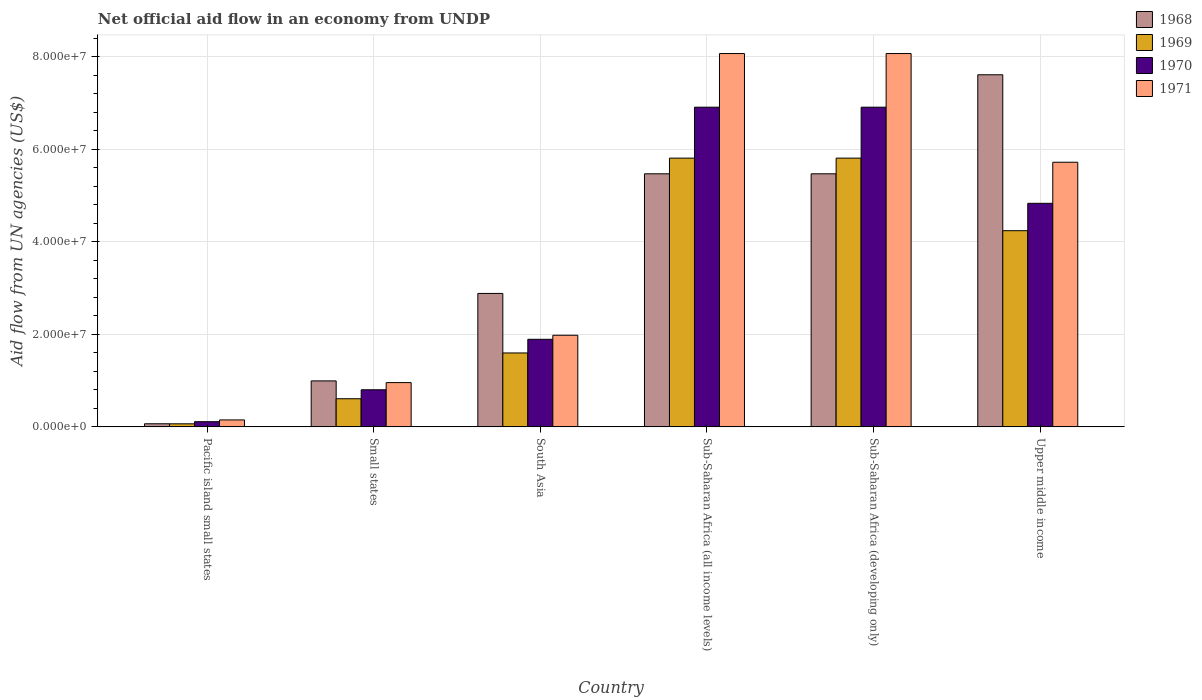Are the number of bars per tick equal to the number of legend labels?
Ensure brevity in your answer.  Yes. How many bars are there on the 5th tick from the right?
Provide a succinct answer. 4. What is the label of the 4th group of bars from the left?
Make the answer very short. Sub-Saharan Africa (all income levels). What is the net official aid flow in 1968 in South Asia?
Provide a short and direct response. 2.88e+07. Across all countries, what is the maximum net official aid flow in 1970?
Provide a short and direct response. 6.91e+07. Across all countries, what is the minimum net official aid flow in 1971?
Your answer should be very brief. 1.50e+06. In which country was the net official aid flow in 1970 maximum?
Your answer should be very brief. Sub-Saharan Africa (all income levels). In which country was the net official aid flow in 1969 minimum?
Ensure brevity in your answer.  Pacific island small states. What is the total net official aid flow in 1968 in the graph?
Your answer should be very brief. 2.25e+08. What is the difference between the net official aid flow in 1971 in Sub-Saharan Africa (developing only) and that in Upper middle income?
Your answer should be compact. 2.35e+07. What is the difference between the net official aid flow in 1968 in Small states and the net official aid flow in 1969 in South Asia?
Offer a very short reply. -6.04e+06. What is the average net official aid flow in 1970 per country?
Your answer should be compact. 3.58e+07. What is the difference between the net official aid flow of/in 1968 and net official aid flow of/in 1971 in Pacific island small states?
Provide a short and direct response. -8.30e+05. What is the ratio of the net official aid flow in 1968 in South Asia to that in Sub-Saharan Africa (developing only)?
Offer a very short reply. 0.53. Is the net official aid flow in 1969 in South Asia less than that in Sub-Saharan Africa (all income levels)?
Provide a short and direct response. Yes. Is the difference between the net official aid flow in 1968 in Pacific island small states and Sub-Saharan Africa (developing only) greater than the difference between the net official aid flow in 1971 in Pacific island small states and Sub-Saharan Africa (developing only)?
Make the answer very short. Yes. What is the difference between the highest and the second highest net official aid flow in 1970?
Provide a succinct answer. 2.08e+07. What is the difference between the highest and the lowest net official aid flow in 1969?
Offer a terse response. 5.74e+07. Is it the case that in every country, the sum of the net official aid flow in 1971 and net official aid flow in 1969 is greater than the sum of net official aid flow in 1968 and net official aid flow in 1970?
Provide a short and direct response. No. What does the 4th bar from the left in South Asia represents?
Your answer should be compact. 1971. What does the 4th bar from the right in Sub-Saharan Africa (developing only) represents?
Keep it short and to the point. 1968. Is it the case that in every country, the sum of the net official aid flow in 1969 and net official aid flow in 1971 is greater than the net official aid flow in 1970?
Offer a terse response. Yes. How many bars are there?
Your answer should be very brief. 24. Are all the bars in the graph horizontal?
Make the answer very short. No. What is the difference between two consecutive major ticks on the Y-axis?
Give a very brief answer. 2.00e+07. Does the graph contain any zero values?
Give a very brief answer. No. Where does the legend appear in the graph?
Provide a short and direct response. Top right. What is the title of the graph?
Provide a short and direct response. Net official aid flow in an economy from UNDP. Does "1981" appear as one of the legend labels in the graph?
Your answer should be compact. No. What is the label or title of the X-axis?
Your response must be concise. Country. What is the label or title of the Y-axis?
Give a very brief answer. Aid flow from UN agencies (US$). What is the Aid flow from UN agencies (US$) in 1968 in Pacific island small states?
Your answer should be very brief. 6.70e+05. What is the Aid flow from UN agencies (US$) of 1970 in Pacific island small states?
Offer a very short reply. 1.12e+06. What is the Aid flow from UN agencies (US$) in 1971 in Pacific island small states?
Make the answer very short. 1.50e+06. What is the Aid flow from UN agencies (US$) of 1968 in Small states?
Ensure brevity in your answer.  9.94e+06. What is the Aid flow from UN agencies (US$) in 1969 in Small states?
Make the answer very short. 6.08e+06. What is the Aid flow from UN agencies (US$) in 1970 in Small states?
Offer a very short reply. 8.02e+06. What is the Aid flow from UN agencies (US$) of 1971 in Small states?
Give a very brief answer. 9.57e+06. What is the Aid flow from UN agencies (US$) of 1968 in South Asia?
Offer a very short reply. 2.88e+07. What is the Aid flow from UN agencies (US$) of 1969 in South Asia?
Your response must be concise. 1.60e+07. What is the Aid flow from UN agencies (US$) in 1970 in South Asia?
Provide a succinct answer. 1.89e+07. What is the Aid flow from UN agencies (US$) of 1971 in South Asia?
Provide a short and direct response. 1.98e+07. What is the Aid flow from UN agencies (US$) in 1968 in Sub-Saharan Africa (all income levels)?
Offer a terse response. 5.47e+07. What is the Aid flow from UN agencies (US$) of 1969 in Sub-Saharan Africa (all income levels)?
Offer a terse response. 5.81e+07. What is the Aid flow from UN agencies (US$) of 1970 in Sub-Saharan Africa (all income levels)?
Provide a short and direct response. 6.91e+07. What is the Aid flow from UN agencies (US$) of 1971 in Sub-Saharan Africa (all income levels)?
Your answer should be very brief. 8.07e+07. What is the Aid flow from UN agencies (US$) in 1968 in Sub-Saharan Africa (developing only)?
Provide a short and direct response. 5.47e+07. What is the Aid flow from UN agencies (US$) of 1969 in Sub-Saharan Africa (developing only)?
Ensure brevity in your answer.  5.81e+07. What is the Aid flow from UN agencies (US$) in 1970 in Sub-Saharan Africa (developing only)?
Offer a very short reply. 6.91e+07. What is the Aid flow from UN agencies (US$) in 1971 in Sub-Saharan Africa (developing only)?
Offer a terse response. 8.07e+07. What is the Aid flow from UN agencies (US$) of 1968 in Upper middle income?
Keep it short and to the point. 7.61e+07. What is the Aid flow from UN agencies (US$) of 1969 in Upper middle income?
Make the answer very short. 4.24e+07. What is the Aid flow from UN agencies (US$) of 1970 in Upper middle income?
Provide a short and direct response. 4.83e+07. What is the Aid flow from UN agencies (US$) of 1971 in Upper middle income?
Keep it short and to the point. 5.72e+07. Across all countries, what is the maximum Aid flow from UN agencies (US$) of 1968?
Ensure brevity in your answer.  7.61e+07. Across all countries, what is the maximum Aid flow from UN agencies (US$) in 1969?
Offer a terse response. 5.81e+07. Across all countries, what is the maximum Aid flow from UN agencies (US$) in 1970?
Your answer should be very brief. 6.91e+07. Across all countries, what is the maximum Aid flow from UN agencies (US$) of 1971?
Ensure brevity in your answer.  8.07e+07. Across all countries, what is the minimum Aid flow from UN agencies (US$) of 1968?
Give a very brief answer. 6.70e+05. Across all countries, what is the minimum Aid flow from UN agencies (US$) in 1969?
Make the answer very short. 6.60e+05. Across all countries, what is the minimum Aid flow from UN agencies (US$) in 1970?
Your answer should be compact. 1.12e+06. Across all countries, what is the minimum Aid flow from UN agencies (US$) in 1971?
Offer a terse response. 1.50e+06. What is the total Aid flow from UN agencies (US$) of 1968 in the graph?
Offer a very short reply. 2.25e+08. What is the total Aid flow from UN agencies (US$) of 1969 in the graph?
Offer a terse response. 1.81e+08. What is the total Aid flow from UN agencies (US$) in 1970 in the graph?
Your response must be concise. 2.15e+08. What is the total Aid flow from UN agencies (US$) of 1971 in the graph?
Your response must be concise. 2.50e+08. What is the difference between the Aid flow from UN agencies (US$) in 1968 in Pacific island small states and that in Small states?
Keep it short and to the point. -9.27e+06. What is the difference between the Aid flow from UN agencies (US$) in 1969 in Pacific island small states and that in Small states?
Your answer should be very brief. -5.42e+06. What is the difference between the Aid flow from UN agencies (US$) in 1970 in Pacific island small states and that in Small states?
Your answer should be very brief. -6.90e+06. What is the difference between the Aid flow from UN agencies (US$) in 1971 in Pacific island small states and that in Small states?
Make the answer very short. -8.07e+06. What is the difference between the Aid flow from UN agencies (US$) in 1968 in Pacific island small states and that in South Asia?
Give a very brief answer. -2.82e+07. What is the difference between the Aid flow from UN agencies (US$) in 1969 in Pacific island small states and that in South Asia?
Give a very brief answer. -1.53e+07. What is the difference between the Aid flow from UN agencies (US$) in 1970 in Pacific island small states and that in South Asia?
Your response must be concise. -1.78e+07. What is the difference between the Aid flow from UN agencies (US$) in 1971 in Pacific island small states and that in South Asia?
Give a very brief answer. -1.83e+07. What is the difference between the Aid flow from UN agencies (US$) in 1968 in Pacific island small states and that in Sub-Saharan Africa (all income levels)?
Your answer should be compact. -5.40e+07. What is the difference between the Aid flow from UN agencies (US$) in 1969 in Pacific island small states and that in Sub-Saharan Africa (all income levels)?
Provide a short and direct response. -5.74e+07. What is the difference between the Aid flow from UN agencies (US$) of 1970 in Pacific island small states and that in Sub-Saharan Africa (all income levels)?
Make the answer very short. -6.80e+07. What is the difference between the Aid flow from UN agencies (US$) of 1971 in Pacific island small states and that in Sub-Saharan Africa (all income levels)?
Your response must be concise. -7.92e+07. What is the difference between the Aid flow from UN agencies (US$) of 1968 in Pacific island small states and that in Sub-Saharan Africa (developing only)?
Provide a succinct answer. -5.40e+07. What is the difference between the Aid flow from UN agencies (US$) in 1969 in Pacific island small states and that in Sub-Saharan Africa (developing only)?
Your answer should be very brief. -5.74e+07. What is the difference between the Aid flow from UN agencies (US$) of 1970 in Pacific island small states and that in Sub-Saharan Africa (developing only)?
Make the answer very short. -6.80e+07. What is the difference between the Aid flow from UN agencies (US$) of 1971 in Pacific island small states and that in Sub-Saharan Africa (developing only)?
Offer a very short reply. -7.92e+07. What is the difference between the Aid flow from UN agencies (US$) in 1968 in Pacific island small states and that in Upper middle income?
Offer a very short reply. -7.54e+07. What is the difference between the Aid flow from UN agencies (US$) of 1969 in Pacific island small states and that in Upper middle income?
Offer a very short reply. -4.18e+07. What is the difference between the Aid flow from UN agencies (US$) in 1970 in Pacific island small states and that in Upper middle income?
Your answer should be compact. -4.72e+07. What is the difference between the Aid flow from UN agencies (US$) in 1971 in Pacific island small states and that in Upper middle income?
Provide a succinct answer. -5.57e+07. What is the difference between the Aid flow from UN agencies (US$) of 1968 in Small states and that in South Asia?
Your answer should be compact. -1.89e+07. What is the difference between the Aid flow from UN agencies (US$) of 1969 in Small states and that in South Asia?
Ensure brevity in your answer.  -9.90e+06. What is the difference between the Aid flow from UN agencies (US$) of 1970 in Small states and that in South Asia?
Ensure brevity in your answer.  -1.09e+07. What is the difference between the Aid flow from UN agencies (US$) of 1971 in Small states and that in South Asia?
Your answer should be very brief. -1.02e+07. What is the difference between the Aid flow from UN agencies (US$) of 1968 in Small states and that in Sub-Saharan Africa (all income levels)?
Offer a terse response. -4.48e+07. What is the difference between the Aid flow from UN agencies (US$) of 1969 in Small states and that in Sub-Saharan Africa (all income levels)?
Provide a short and direct response. -5.20e+07. What is the difference between the Aid flow from UN agencies (US$) of 1970 in Small states and that in Sub-Saharan Africa (all income levels)?
Your answer should be compact. -6.11e+07. What is the difference between the Aid flow from UN agencies (US$) in 1971 in Small states and that in Sub-Saharan Africa (all income levels)?
Give a very brief answer. -7.11e+07. What is the difference between the Aid flow from UN agencies (US$) of 1968 in Small states and that in Sub-Saharan Africa (developing only)?
Make the answer very short. -4.48e+07. What is the difference between the Aid flow from UN agencies (US$) of 1969 in Small states and that in Sub-Saharan Africa (developing only)?
Your answer should be compact. -5.20e+07. What is the difference between the Aid flow from UN agencies (US$) of 1970 in Small states and that in Sub-Saharan Africa (developing only)?
Offer a very short reply. -6.11e+07. What is the difference between the Aid flow from UN agencies (US$) in 1971 in Small states and that in Sub-Saharan Africa (developing only)?
Ensure brevity in your answer.  -7.11e+07. What is the difference between the Aid flow from UN agencies (US$) in 1968 in Small states and that in Upper middle income?
Ensure brevity in your answer.  -6.62e+07. What is the difference between the Aid flow from UN agencies (US$) in 1969 in Small states and that in Upper middle income?
Your response must be concise. -3.63e+07. What is the difference between the Aid flow from UN agencies (US$) in 1970 in Small states and that in Upper middle income?
Offer a very short reply. -4.03e+07. What is the difference between the Aid flow from UN agencies (US$) in 1971 in Small states and that in Upper middle income?
Your answer should be compact. -4.76e+07. What is the difference between the Aid flow from UN agencies (US$) in 1968 in South Asia and that in Sub-Saharan Africa (all income levels)?
Provide a succinct answer. -2.59e+07. What is the difference between the Aid flow from UN agencies (US$) in 1969 in South Asia and that in Sub-Saharan Africa (all income levels)?
Offer a very short reply. -4.21e+07. What is the difference between the Aid flow from UN agencies (US$) of 1970 in South Asia and that in Sub-Saharan Africa (all income levels)?
Offer a terse response. -5.02e+07. What is the difference between the Aid flow from UN agencies (US$) of 1971 in South Asia and that in Sub-Saharan Africa (all income levels)?
Ensure brevity in your answer.  -6.09e+07. What is the difference between the Aid flow from UN agencies (US$) in 1968 in South Asia and that in Sub-Saharan Africa (developing only)?
Keep it short and to the point. -2.59e+07. What is the difference between the Aid flow from UN agencies (US$) of 1969 in South Asia and that in Sub-Saharan Africa (developing only)?
Provide a short and direct response. -4.21e+07. What is the difference between the Aid flow from UN agencies (US$) in 1970 in South Asia and that in Sub-Saharan Africa (developing only)?
Offer a terse response. -5.02e+07. What is the difference between the Aid flow from UN agencies (US$) in 1971 in South Asia and that in Sub-Saharan Africa (developing only)?
Give a very brief answer. -6.09e+07. What is the difference between the Aid flow from UN agencies (US$) in 1968 in South Asia and that in Upper middle income?
Make the answer very short. -4.73e+07. What is the difference between the Aid flow from UN agencies (US$) in 1969 in South Asia and that in Upper middle income?
Ensure brevity in your answer.  -2.64e+07. What is the difference between the Aid flow from UN agencies (US$) of 1970 in South Asia and that in Upper middle income?
Ensure brevity in your answer.  -2.94e+07. What is the difference between the Aid flow from UN agencies (US$) of 1971 in South Asia and that in Upper middle income?
Provide a short and direct response. -3.74e+07. What is the difference between the Aid flow from UN agencies (US$) of 1968 in Sub-Saharan Africa (all income levels) and that in Sub-Saharan Africa (developing only)?
Offer a very short reply. 0. What is the difference between the Aid flow from UN agencies (US$) of 1971 in Sub-Saharan Africa (all income levels) and that in Sub-Saharan Africa (developing only)?
Your answer should be very brief. 0. What is the difference between the Aid flow from UN agencies (US$) of 1968 in Sub-Saharan Africa (all income levels) and that in Upper middle income?
Make the answer very short. -2.14e+07. What is the difference between the Aid flow from UN agencies (US$) of 1969 in Sub-Saharan Africa (all income levels) and that in Upper middle income?
Your answer should be very brief. 1.57e+07. What is the difference between the Aid flow from UN agencies (US$) in 1970 in Sub-Saharan Africa (all income levels) and that in Upper middle income?
Offer a terse response. 2.08e+07. What is the difference between the Aid flow from UN agencies (US$) of 1971 in Sub-Saharan Africa (all income levels) and that in Upper middle income?
Provide a succinct answer. 2.35e+07. What is the difference between the Aid flow from UN agencies (US$) in 1968 in Sub-Saharan Africa (developing only) and that in Upper middle income?
Provide a short and direct response. -2.14e+07. What is the difference between the Aid flow from UN agencies (US$) of 1969 in Sub-Saharan Africa (developing only) and that in Upper middle income?
Your answer should be compact. 1.57e+07. What is the difference between the Aid flow from UN agencies (US$) of 1970 in Sub-Saharan Africa (developing only) and that in Upper middle income?
Offer a terse response. 2.08e+07. What is the difference between the Aid flow from UN agencies (US$) in 1971 in Sub-Saharan Africa (developing only) and that in Upper middle income?
Your response must be concise. 2.35e+07. What is the difference between the Aid flow from UN agencies (US$) in 1968 in Pacific island small states and the Aid flow from UN agencies (US$) in 1969 in Small states?
Your response must be concise. -5.41e+06. What is the difference between the Aid flow from UN agencies (US$) in 1968 in Pacific island small states and the Aid flow from UN agencies (US$) in 1970 in Small states?
Offer a very short reply. -7.35e+06. What is the difference between the Aid flow from UN agencies (US$) of 1968 in Pacific island small states and the Aid flow from UN agencies (US$) of 1971 in Small states?
Offer a terse response. -8.90e+06. What is the difference between the Aid flow from UN agencies (US$) in 1969 in Pacific island small states and the Aid flow from UN agencies (US$) in 1970 in Small states?
Offer a terse response. -7.36e+06. What is the difference between the Aid flow from UN agencies (US$) of 1969 in Pacific island small states and the Aid flow from UN agencies (US$) of 1971 in Small states?
Make the answer very short. -8.91e+06. What is the difference between the Aid flow from UN agencies (US$) in 1970 in Pacific island small states and the Aid flow from UN agencies (US$) in 1971 in Small states?
Offer a terse response. -8.45e+06. What is the difference between the Aid flow from UN agencies (US$) in 1968 in Pacific island small states and the Aid flow from UN agencies (US$) in 1969 in South Asia?
Offer a very short reply. -1.53e+07. What is the difference between the Aid flow from UN agencies (US$) of 1968 in Pacific island small states and the Aid flow from UN agencies (US$) of 1970 in South Asia?
Give a very brief answer. -1.83e+07. What is the difference between the Aid flow from UN agencies (US$) in 1968 in Pacific island small states and the Aid flow from UN agencies (US$) in 1971 in South Asia?
Your answer should be very brief. -1.91e+07. What is the difference between the Aid flow from UN agencies (US$) of 1969 in Pacific island small states and the Aid flow from UN agencies (US$) of 1970 in South Asia?
Provide a short and direct response. -1.83e+07. What is the difference between the Aid flow from UN agencies (US$) of 1969 in Pacific island small states and the Aid flow from UN agencies (US$) of 1971 in South Asia?
Ensure brevity in your answer.  -1.92e+07. What is the difference between the Aid flow from UN agencies (US$) of 1970 in Pacific island small states and the Aid flow from UN agencies (US$) of 1971 in South Asia?
Keep it short and to the point. -1.87e+07. What is the difference between the Aid flow from UN agencies (US$) of 1968 in Pacific island small states and the Aid flow from UN agencies (US$) of 1969 in Sub-Saharan Africa (all income levels)?
Your answer should be very brief. -5.74e+07. What is the difference between the Aid flow from UN agencies (US$) in 1968 in Pacific island small states and the Aid flow from UN agencies (US$) in 1970 in Sub-Saharan Africa (all income levels)?
Offer a terse response. -6.84e+07. What is the difference between the Aid flow from UN agencies (US$) of 1968 in Pacific island small states and the Aid flow from UN agencies (US$) of 1971 in Sub-Saharan Africa (all income levels)?
Make the answer very short. -8.00e+07. What is the difference between the Aid flow from UN agencies (US$) in 1969 in Pacific island small states and the Aid flow from UN agencies (US$) in 1970 in Sub-Saharan Africa (all income levels)?
Ensure brevity in your answer.  -6.84e+07. What is the difference between the Aid flow from UN agencies (US$) in 1969 in Pacific island small states and the Aid flow from UN agencies (US$) in 1971 in Sub-Saharan Africa (all income levels)?
Offer a very short reply. -8.00e+07. What is the difference between the Aid flow from UN agencies (US$) in 1970 in Pacific island small states and the Aid flow from UN agencies (US$) in 1971 in Sub-Saharan Africa (all income levels)?
Offer a very short reply. -7.96e+07. What is the difference between the Aid flow from UN agencies (US$) in 1968 in Pacific island small states and the Aid flow from UN agencies (US$) in 1969 in Sub-Saharan Africa (developing only)?
Offer a very short reply. -5.74e+07. What is the difference between the Aid flow from UN agencies (US$) in 1968 in Pacific island small states and the Aid flow from UN agencies (US$) in 1970 in Sub-Saharan Africa (developing only)?
Your answer should be compact. -6.84e+07. What is the difference between the Aid flow from UN agencies (US$) in 1968 in Pacific island small states and the Aid flow from UN agencies (US$) in 1971 in Sub-Saharan Africa (developing only)?
Offer a very short reply. -8.00e+07. What is the difference between the Aid flow from UN agencies (US$) of 1969 in Pacific island small states and the Aid flow from UN agencies (US$) of 1970 in Sub-Saharan Africa (developing only)?
Offer a very short reply. -6.84e+07. What is the difference between the Aid flow from UN agencies (US$) of 1969 in Pacific island small states and the Aid flow from UN agencies (US$) of 1971 in Sub-Saharan Africa (developing only)?
Provide a succinct answer. -8.00e+07. What is the difference between the Aid flow from UN agencies (US$) in 1970 in Pacific island small states and the Aid flow from UN agencies (US$) in 1971 in Sub-Saharan Africa (developing only)?
Keep it short and to the point. -7.96e+07. What is the difference between the Aid flow from UN agencies (US$) in 1968 in Pacific island small states and the Aid flow from UN agencies (US$) in 1969 in Upper middle income?
Give a very brief answer. -4.17e+07. What is the difference between the Aid flow from UN agencies (US$) of 1968 in Pacific island small states and the Aid flow from UN agencies (US$) of 1970 in Upper middle income?
Ensure brevity in your answer.  -4.77e+07. What is the difference between the Aid flow from UN agencies (US$) in 1968 in Pacific island small states and the Aid flow from UN agencies (US$) in 1971 in Upper middle income?
Your answer should be compact. -5.65e+07. What is the difference between the Aid flow from UN agencies (US$) of 1969 in Pacific island small states and the Aid flow from UN agencies (US$) of 1970 in Upper middle income?
Your answer should be compact. -4.77e+07. What is the difference between the Aid flow from UN agencies (US$) of 1969 in Pacific island small states and the Aid flow from UN agencies (US$) of 1971 in Upper middle income?
Your answer should be very brief. -5.66e+07. What is the difference between the Aid flow from UN agencies (US$) in 1970 in Pacific island small states and the Aid flow from UN agencies (US$) in 1971 in Upper middle income?
Provide a succinct answer. -5.61e+07. What is the difference between the Aid flow from UN agencies (US$) in 1968 in Small states and the Aid flow from UN agencies (US$) in 1969 in South Asia?
Your answer should be compact. -6.04e+06. What is the difference between the Aid flow from UN agencies (US$) of 1968 in Small states and the Aid flow from UN agencies (US$) of 1970 in South Asia?
Provide a short and direct response. -8.99e+06. What is the difference between the Aid flow from UN agencies (US$) in 1968 in Small states and the Aid flow from UN agencies (US$) in 1971 in South Asia?
Your answer should be compact. -9.87e+06. What is the difference between the Aid flow from UN agencies (US$) in 1969 in Small states and the Aid flow from UN agencies (US$) in 1970 in South Asia?
Keep it short and to the point. -1.28e+07. What is the difference between the Aid flow from UN agencies (US$) in 1969 in Small states and the Aid flow from UN agencies (US$) in 1971 in South Asia?
Your response must be concise. -1.37e+07. What is the difference between the Aid flow from UN agencies (US$) of 1970 in Small states and the Aid flow from UN agencies (US$) of 1971 in South Asia?
Offer a very short reply. -1.18e+07. What is the difference between the Aid flow from UN agencies (US$) of 1968 in Small states and the Aid flow from UN agencies (US$) of 1969 in Sub-Saharan Africa (all income levels)?
Your answer should be very brief. -4.82e+07. What is the difference between the Aid flow from UN agencies (US$) of 1968 in Small states and the Aid flow from UN agencies (US$) of 1970 in Sub-Saharan Africa (all income levels)?
Your answer should be compact. -5.92e+07. What is the difference between the Aid flow from UN agencies (US$) of 1968 in Small states and the Aid flow from UN agencies (US$) of 1971 in Sub-Saharan Africa (all income levels)?
Provide a short and direct response. -7.08e+07. What is the difference between the Aid flow from UN agencies (US$) in 1969 in Small states and the Aid flow from UN agencies (US$) in 1970 in Sub-Saharan Africa (all income levels)?
Provide a short and direct response. -6.30e+07. What is the difference between the Aid flow from UN agencies (US$) in 1969 in Small states and the Aid flow from UN agencies (US$) in 1971 in Sub-Saharan Africa (all income levels)?
Ensure brevity in your answer.  -7.46e+07. What is the difference between the Aid flow from UN agencies (US$) in 1970 in Small states and the Aid flow from UN agencies (US$) in 1971 in Sub-Saharan Africa (all income levels)?
Give a very brief answer. -7.27e+07. What is the difference between the Aid flow from UN agencies (US$) in 1968 in Small states and the Aid flow from UN agencies (US$) in 1969 in Sub-Saharan Africa (developing only)?
Your answer should be very brief. -4.82e+07. What is the difference between the Aid flow from UN agencies (US$) in 1968 in Small states and the Aid flow from UN agencies (US$) in 1970 in Sub-Saharan Africa (developing only)?
Provide a succinct answer. -5.92e+07. What is the difference between the Aid flow from UN agencies (US$) in 1968 in Small states and the Aid flow from UN agencies (US$) in 1971 in Sub-Saharan Africa (developing only)?
Ensure brevity in your answer.  -7.08e+07. What is the difference between the Aid flow from UN agencies (US$) of 1969 in Small states and the Aid flow from UN agencies (US$) of 1970 in Sub-Saharan Africa (developing only)?
Your answer should be compact. -6.30e+07. What is the difference between the Aid flow from UN agencies (US$) in 1969 in Small states and the Aid flow from UN agencies (US$) in 1971 in Sub-Saharan Africa (developing only)?
Give a very brief answer. -7.46e+07. What is the difference between the Aid flow from UN agencies (US$) in 1970 in Small states and the Aid flow from UN agencies (US$) in 1971 in Sub-Saharan Africa (developing only)?
Provide a short and direct response. -7.27e+07. What is the difference between the Aid flow from UN agencies (US$) of 1968 in Small states and the Aid flow from UN agencies (US$) of 1969 in Upper middle income?
Your answer should be very brief. -3.25e+07. What is the difference between the Aid flow from UN agencies (US$) in 1968 in Small states and the Aid flow from UN agencies (US$) in 1970 in Upper middle income?
Give a very brief answer. -3.84e+07. What is the difference between the Aid flow from UN agencies (US$) of 1968 in Small states and the Aid flow from UN agencies (US$) of 1971 in Upper middle income?
Offer a terse response. -4.73e+07. What is the difference between the Aid flow from UN agencies (US$) of 1969 in Small states and the Aid flow from UN agencies (US$) of 1970 in Upper middle income?
Keep it short and to the point. -4.22e+07. What is the difference between the Aid flow from UN agencies (US$) of 1969 in Small states and the Aid flow from UN agencies (US$) of 1971 in Upper middle income?
Provide a short and direct response. -5.11e+07. What is the difference between the Aid flow from UN agencies (US$) in 1970 in Small states and the Aid flow from UN agencies (US$) in 1971 in Upper middle income?
Your answer should be compact. -4.92e+07. What is the difference between the Aid flow from UN agencies (US$) of 1968 in South Asia and the Aid flow from UN agencies (US$) of 1969 in Sub-Saharan Africa (all income levels)?
Ensure brevity in your answer.  -2.92e+07. What is the difference between the Aid flow from UN agencies (US$) of 1968 in South Asia and the Aid flow from UN agencies (US$) of 1970 in Sub-Saharan Africa (all income levels)?
Make the answer very short. -4.03e+07. What is the difference between the Aid flow from UN agencies (US$) of 1968 in South Asia and the Aid flow from UN agencies (US$) of 1971 in Sub-Saharan Africa (all income levels)?
Your answer should be compact. -5.19e+07. What is the difference between the Aid flow from UN agencies (US$) in 1969 in South Asia and the Aid flow from UN agencies (US$) in 1970 in Sub-Saharan Africa (all income levels)?
Your answer should be compact. -5.31e+07. What is the difference between the Aid flow from UN agencies (US$) of 1969 in South Asia and the Aid flow from UN agencies (US$) of 1971 in Sub-Saharan Africa (all income levels)?
Make the answer very short. -6.47e+07. What is the difference between the Aid flow from UN agencies (US$) in 1970 in South Asia and the Aid flow from UN agencies (US$) in 1971 in Sub-Saharan Africa (all income levels)?
Ensure brevity in your answer.  -6.18e+07. What is the difference between the Aid flow from UN agencies (US$) in 1968 in South Asia and the Aid flow from UN agencies (US$) in 1969 in Sub-Saharan Africa (developing only)?
Provide a succinct answer. -2.92e+07. What is the difference between the Aid flow from UN agencies (US$) in 1968 in South Asia and the Aid flow from UN agencies (US$) in 1970 in Sub-Saharan Africa (developing only)?
Keep it short and to the point. -4.03e+07. What is the difference between the Aid flow from UN agencies (US$) in 1968 in South Asia and the Aid flow from UN agencies (US$) in 1971 in Sub-Saharan Africa (developing only)?
Your response must be concise. -5.19e+07. What is the difference between the Aid flow from UN agencies (US$) of 1969 in South Asia and the Aid flow from UN agencies (US$) of 1970 in Sub-Saharan Africa (developing only)?
Make the answer very short. -5.31e+07. What is the difference between the Aid flow from UN agencies (US$) of 1969 in South Asia and the Aid flow from UN agencies (US$) of 1971 in Sub-Saharan Africa (developing only)?
Offer a terse response. -6.47e+07. What is the difference between the Aid flow from UN agencies (US$) of 1970 in South Asia and the Aid flow from UN agencies (US$) of 1971 in Sub-Saharan Africa (developing only)?
Offer a terse response. -6.18e+07. What is the difference between the Aid flow from UN agencies (US$) of 1968 in South Asia and the Aid flow from UN agencies (US$) of 1969 in Upper middle income?
Your answer should be very brief. -1.36e+07. What is the difference between the Aid flow from UN agencies (US$) in 1968 in South Asia and the Aid flow from UN agencies (US$) in 1970 in Upper middle income?
Offer a terse response. -1.95e+07. What is the difference between the Aid flow from UN agencies (US$) of 1968 in South Asia and the Aid flow from UN agencies (US$) of 1971 in Upper middle income?
Provide a short and direct response. -2.84e+07. What is the difference between the Aid flow from UN agencies (US$) of 1969 in South Asia and the Aid flow from UN agencies (US$) of 1970 in Upper middle income?
Ensure brevity in your answer.  -3.24e+07. What is the difference between the Aid flow from UN agencies (US$) of 1969 in South Asia and the Aid flow from UN agencies (US$) of 1971 in Upper middle income?
Give a very brief answer. -4.12e+07. What is the difference between the Aid flow from UN agencies (US$) in 1970 in South Asia and the Aid flow from UN agencies (US$) in 1971 in Upper middle income?
Give a very brief answer. -3.83e+07. What is the difference between the Aid flow from UN agencies (US$) of 1968 in Sub-Saharan Africa (all income levels) and the Aid flow from UN agencies (US$) of 1969 in Sub-Saharan Africa (developing only)?
Your response must be concise. -3.39e+06. What is the difference between the Aid flow from UN agencies (US$) in 1968 in Sub-Saharan Africa (all income levels) and the Aid flow from UN agencies (US$) in 1970 in Sub-Saharan Africa (developing only)?
Offer a very short reply. -1.44e+07. What is the difference between the Aid flow from UN agencies (US$) in 1968 in Sub-Saharan Africa (all income levels) and the Aid flow from UN agencies (US$) in 1971 in Sub-Saharan Africa (developing only)?
Make the answer very short. -2.60e+07. What is the difference between the Aid flow from UN agencies (US$) of 1969 in Sub-Saharan Africa (all income levels) and the Aid flow from UN agencies (US$) of 1970 in Sub-Saharan Africa (developing only)?
Give a very brief answer. -1.10e+07. What is the difference between the Aid flow from UN agencies (US$) in 1969 in Sub-Saharan Africa (all income levels) and the Aid flow from UN agencies (US$) in 1971 in Sub-Saharan Africa (developing only)?
Provide a short and direct response. -2.26e+07. What is the difference between the Aid flow from UN agencies (US$) of 1970 in Sub-Saharan Africa (all income levels) and the Aid flow from UN agencies (US$) of 1971 in Sub-Saharan Africa (developing only)?
Keep it short and to the point. -1.16e+07. What is the difference between the Aid flow from UN agencies (US$) of 1968 in Sub-Saharan Africa (all income levels) and the Aid flow from UN agencies (US$) of 1969 in Upper middle income?
Provide a short and direct response. 1.23e+07. What is the difference between the Aid flow from UN agencies (US$) of 1968 in Sub-Saharan Africa (all income levels) and the Aid flow from UN agencies (US$) of 1970 in Upper middle income?
Give a very brief answer. 6.38e+06. What is the difference between the Aid flow from UN agencies (US$) in 1968 in Sub-Saharan Africa (all income levels) and the Aid flow from UN agencies (US$) in 1971 in Upper middle income?
Ensure brevity in your answer.  -2.50e+06. What is the difference between the Aid flow from UN agencies (US$) in 1969 in Sub-Saharan Africa (all income levels) and the Aid flow from UN agencies (US$) in 1970 in Upper middle income?
Ensure brevity in your answer.  9.77e+06. What is the difference between the Aid flow from UN agencies (US$) in 1969 in Sub-Saharan Africa (all income levels) and the Aid flow from UN agencies (US$) in 1971 in Upper middle income?
Offer a terse response. 8.90e+05. What is the difference between the Aid flow from UN agencies (US$) in 1970 in Sub-Saharan Africa (all income levels) and the Aid flow from UN agencies (US$) in 1971 in Upper middle income?
Give a very brief answer. 1.19e+07. What is the difference between the Aid flow from UN agencies (US$) in 1968 in Sub-Saharan Africa (developing only) and the Aid flow from UN agencies (US$) in 1969 in Upper middle income?
Provide a succinct answer. 1.23e+07. What is the difference between the Aid flow from UN agencies (US$) in 1968 in Sub-Saharan Africa (developing only) and the Aid flow from UN agencies (US$) in 1970 in Upper middle income?
Offer a terse response. 6.38e+06. What is the difference between the Aid flow from UN agencies (US$) in 1968 in Sub-Saharan Africa (developing only) and the Aid flow from UN agencies (US$) in 1971 in Upper middle income?
Offer a very short reply. -2.50e+06. What is the difference between the Aid flow from UN agencies (US$) in 1969 in Sub-Saharan Africa (developing only) and the Aid flow from UN agencies (US$) in 1970 in Upper middle income?
Provide a succinct answer. 9.77e+06. What is the difference between the Aid flow from UN agencies (US$) in 1969 in Sub-Saharan Africa (developing only) and the Aid flow from UN agencies (US$) in 1971 in Upper middle income?
Offer a terse response. 8.90e+05. What is the difference between the Aid flow from UN agencies (US$) in 1970 in Sub-Saharan Africa (developing only) and the Aid flow from UN agencies (US$) in 1971 in Upper middle income?
Make the answer very short. 1.19e+07. What is the average Aid flow from UN agencies (US$) in 1968 per country?
Your answer should be very brief. 3.75e+07. What is the average Aid flow from UN agencies (US$) of 1969 per country?
Offer a very short reply. 3.02e+07. What is the average Aid flow from UN agencies (US$) of 1970 per country?
Your answer should be very brief. 3.58e+07. What is the average Aid flow from UN agencies (US$) of 1971 per country?
Make the answer very short. 4.16e+07. What is the difference between the Aid flow from UN agencies (US$) in 1968 and Aid flow from UN agencies (US$) in 1970 in Pacific island small states?
Provide a succinct answer. -4.50e+05. What is the difference between the Aid flow from UN agencies (US$) of 1968 and Aid flow from UN agencies (US$) of 1971 in Pacific island small states?
Give a very brief answer. -8.30e+05. What is the difference between the Aid flow from UN agencies (US$) in 1969 and Aid flow from UN agencies (US$) in 1970 in Pacific island small states?
Your answer should be compact. -4.60e+05. What is the difference between the Aid flow from UN agencies (US$) in 1969 and Aid flow from UN agencies (US$) in 1971 in Pacific island small states?
Your answer should be very brief. -8.40e+05. What is the difference between the Aid flow from UN agencies (US$) of 1970 and Aid flow from UN agencies (US$) of 1971 in Pacific island small states?
Provide a short and direct response. -3.80e+05. What is the difference between the Aid flow from UN agencies (US$) in 1968 and Aid flow from UN agencies (US$) in 1969 in Small states?
Give a very brief answer. 3.86e+06. What is the difference between the Aid flow from UN agencies (US$) of 1968 and Aid flow from UN agencies (US$) of 1970 in Small states?
Your response must be concise. 1.92e+06. What is the difference between the Aid flow from UN agencies (US$) in 1969 and Aid flow from UN agencies (US$) in 1970 in Small states?
Offer a terse response. -1.94e+06. What is the difference between the Aid flow from UN agencies (US$) of 1969 and Aid flow from UN agencies (US$) of 1971 in Small states?
Your answer should be very brief. -3.49e+06. What is the difference between the Aid flow from UN agencies (US$) in 1970 and Aid flow from UN agencies (US$) in 1971 in Small states?
Ensure brevity in your answer.  -1.55e+06. What is the difference between the Aid flow from UN agencies (US$) in 1968 and Aid flow from UN agencies (US$) in 1969 in South Asia?
Your answer should be compact. 1.29e+07. What is the difference between the Aid flow from UN agencies (US$) in 1968 and Aid flow from UN agencies (US$) in 1970 in South Asia?
Give a very brief answer. 9.92e+06. What is the difference between the Aid flow from UN agencies (US$) of 1968 and Aid flow from UN agencies (US$) of 1971 in South Asia?
Keep it short and to the point. 9.04e+06. What is the difference between the Aid flow from UN agencies (US$) of 1969 and Aid flow from UN agencies (US$) of 1970 in South Asia?
Offer a terse response. -2.95e+06. What is the difference between the Aid flow from UN agencies (US$) in 1969 and Aid flow from UN agencies (US$) in 1971 in South Asia?
Make the answer very short. -3.83e+06. What is the difference between the Aid flow from UN agencies (US$) of 1970 and Aid flow from UN agencies (US$) of 1971 in South Asia?
Make the answer very short. -8.80e+05. What is the difference between the Aid flow from UN agencies (US$) in 1968 and Aid flow from UN agencies (US$) in 1969 in Sub-Saharan Africa (all income levels)?
Provide a short and direct response. -3.39e+06. What is the difference between the Aid flow from UN agencies (US$) of 1968 and Aid flow from UN agencies (US$) of 1970 in Sub-Saharan Africa (all income levels)?
Provide a short and direct response. -1.44e+07. What is the difference between the Aid flow from UN agencies (US$) of 1968 and Aid flow from UN agencies (US$) of 1971 in Sub-Saharan Africa (all income levels)?
Make the answer very short. -2.60e+07. What is the difference between the Aid flow from UN agencies (US$) of 1969 and Aid flow from UN agencies (US$) of 1970 in Sub-Saharan Africa (all income levels)?
Your answer should be compact. -1.10e+07. What is the difference between the Aid flow from UN agencies (US$) of 1969 and Aid flow from UN agencies (US$) of 1971 in Sub-Saharan Africa (all income levels)?
Keep it short and to the point. -2.26e+07. What is the difference between the Aid flow from UN agencies (US$) in 1970 and Aid flow from UN agencies (US$) in 1971 in Sub-Saharan Africa (all income levels)?
Offer a very short reply. -1.16e+07. What is the difference between the Aid flow from UN agencies (US$) in 1968 and Aid flow from UN agencies (US$) in 1969 in Sub-Saharan Africa (developing only)?
Give a very brief answer. -3.39e+06. What is the difference between the Aid flow from UN agencies (US$) in 1968 and Aid flow from UN agencies (US$) in 1970 in Sub-Saharan Africa (developing only)?
Offer a terse response. -1.44e+07. What is the difference between the Aid flow from UN agencies (US$) in 1968 and Aid flow from UN agencies (US$) in 1971 in Sub-Saharan Africa (developing only)?
Ensure brevity in your answer.  -2.60e+07. What is the difference between the Aid flow from UN agencies (US$) in 1969 and Aid flow from UN agencies (US$) in 1970 in Sub-Saharan Africa (developing only)?
Make the answer very short. -1.10e+07. What is the difference between the Aid flow from UN agencies (US$) of 1969 and Aid flow from UN agencies (US$) of 1971 in Sub-Saharan Africa (developing only)?
Keep it short and to the point. -2.26e+07. What is the difference between the Aid flow from UN agencies (US$) of 1970 and Aid flow from UN agencies (US$) of 1971 in Sub-Saharan Africa (developing only)?
Give a very brief answer. -1.16e+07. What is the difference between the Aid flow from UN agencies (US$) in 1968 and Aid flow from UN agencies (US$) in 1969 in Upper middle income?
Your answer should be compact. 3.37e+07. What is the difference between the Aid flow from UN agencies (US$) of 1968 and Aid flow from UN agencies (US$) of 1970 in Upper middle income?
Provide a short and direct response. 2.78e+07. What is the difference between the Aid flow from UN agencies (US$) of 1968 and Aid flow from UN agencies (US$) of 1971 in Upper middle income?
Offer a terse response. 1.89e+07. What is the difference between the Aid flow from UN agencies (US$) of 1969 and Aid flow from UN agencies (US$) of 1970 in Upper middle income?
Offer a very short reply. -5.92e+06. What is the difference between the Aid flow from UN agencies (US$) of 1969 and Aid flow from UN agencies (US$) of 1971 in Upper middle income?
Ensure brevity in your answer.  -1.48e+07. What is the difference between the Aid flow from UN agencies (US$) of 1970 and Aid flow from UN agencies (US$) of 1971 in Upper middle income?
Offer a very short reply. -8.88e+06. What is the ratio of the Aid flow from UN agencies (US$) of 1968 in Pacific island small states to that in Small states?
Keep it short and to the point. 0.07. What is the ratio of the Aid flow from UN agencies (US$) of 1969 in Pacific island small states to that in Small states?
Provide a short and direct response. 0.11. What is the ratio of the Aid flow from UN agencies (US$) in 1970 in Pacific island small states to that in Small states?
Your answer should be very brief. 0.14. What is the ratio of the Aid flow from UN agencies (US$) in 1971 in Pacific island small states to that in Small states?
Provide a short and direct response. 0.16. What is the ratio of the Aid flow from UN agencies (US$) in 1968 in Pacific island small states to that in South Asia?
Your answer should be compact. 0.02. What is the ratio of the Aid flow from UN agencies (US$) of 1969 in Pacific island small states to that in South Asia?
Your answer should be very brief. 0.04. What is the ratio of the Aid flow from UN agencies (US$) in 1970 in Pacific island small states to that in South Asia?
Offer a very short reply. 0.06. What is the ratio of the Aid flow from UN agencies (US$) of 1971 in Pacific island small states to that in South Asia?
Your answer should be compact. 0.08. What is the ratio of the Aid flow from UN agencies (US$) of 1968 in Pacific island small states to that in Sub-Saharan Africa (all income levels)?
Offer a very short reply. 0.01. What is the ratio of the Aid flow from UN agencies (US$) of 1969 in Pacific island small states to that in Sub-Saharan Africa (all income levels)?
Provide a short and direct response. 0.01. What is the ratio of the Aid flow from UN agencies (US$) in 1970 in Pacific island small states to that in Sub-Saharan Africa (all income levels)?
Offer a terse response. 0.02. What is the ratio of the Aid flow from UN agencies (US$) in 1971 in Pacific island small states to that in Sub-Saharan Africa (all income levels)?
Provide a short and direct response. 0.02. What is the ratio of the Aid flow from UN agencies (US$) in 1968 in Pacific island small states to that in Sub-Saharan Africa (developing only)?
Offer a very short reply. 0.01. What is the ratio of the Aid flow from UN agencies (US$) of 1969 in Pacific island small states to that in Sub-Saharan Africa (developing only)?
Ensure brevity in your answer.  0.01. What is the ratio of the Aid flow from UN agencies (US$) of 1970 in Pacific island small states to that in Sub-Saharan Africa (developing only)?
Provide a succinct answer. 0.02. What is the ratio of the Aid flow from UN agencies (US$) of 1971 in Pacific island small states to that in Sub-Saharan Africa (developing only)?
Your answer should be compact. 0.02. What is the ratio of the Aid flow from UN agencies (US$) in 1968 in Pacific island small states to that in Upper middle income?
Keep it short and to the point. 0.01. What is the ratio of the Aid flow from UN agencies (US$) in 1969 in Pacific island small states to that in Upper middle income?
Provide a succinct answer. 0.02. What is the ratio of the Aid flow from UN agencies (US$) of 1970 in Pacific island small states to that in Upper middle income?
Your answer should be very brief. 0.02. What is the ratio of the Aid flow from UN agencies (US$) of 1971 in Pacific island small states to that in Upper middle income?
Give a very brief answer. 0.03. What is the ratio of the Aid flow from UN agencies (US$) in 1968 in Small states to that in South Asia?
Offer a very short reply. 0.34. What is the ratio of the Aid flow from UN agencies (US$) of 1969 in Small states to that in South Asia?
Your response must be concise. 0.38. What is the ratio of the Aid flow from UN agencies (US$) of 1970 in Small states to that in South Asia?
Give a very brief answer. 0.42. What is the ratio of the Aid flow from UN agencies (US$) in 1971 in Small states to that in South Asia?
Your answer should be very brief. 0.48. What is the ratio of the Aid flow from UN agencies (US$) in 1968 in Small states to that in Sub-Saharan Africa (all income levels)?
Give a very brief answer. 0.18. What is the ratio of the Aid flow from UN agencies (US$) of 1969 in Small states to that in Sub-Saharan Africa (all income levels)?
Give a very brief answer. 0.1. What is the ratio of the Aid flow from UN agencies (US$) in 1970 in Small states to that in Sub-Saharan Africa (all income levels)?
Offer a very short reply. 0.12. What is the ratio of the Aid flow from UN agencies (US$) in 1971 in Small states to that in Sub-Saharan Africa (all income levels)?
Your answer should be very brief. 0.12. What is the ratio of the Aid flow from UN agencies (US$) of 1968 in Small states to that in Sub-Saharan Africa (developing only)?
Keep it short and to the point. 0.18. What is the ratio of the Aid flow from UN agencies (US$) in 1969 in Small states to that in Sub-Saharan Africa (developing only)?
Offer a terse response. 0.1. What is the ratio of the Aid flow from UN agencies (US$) of 1970 in Small states to that in Sub-Saharan Africa (developing only)?
Keep it short and to the point. 0.12. What is the ratio of the Aid flow from UN agencies (US$) in 1971 in Small states to that in Sub-Saharan Africa (developing only)?
Keep it short and to the point. 0.12. What is the ratio of the Aid flow from UN agencies (US$) in 1968 in Small states to that in Upper middle income?
Your answer should be very brief. 0.13. What is the ratio of the Aid flow from UN agencies (US$) of 1969 in Small states to that in Upper middle income?
Offer a very short reply. 0.14. What is the ratio of the Aid flow from UN agencies (US$) of 1970 in Small states to that in Upper middle income?
Your response must be concise. 0.17. What is the ratio of the Aid flow from UN agencies (US$) in 1971 in Small states to that in Upper middle income?
Your answer should be compact. 0.17. What is the ratio of the Aid flow from UN agencies (US$) in 1968 in South Asia to that in Sub-Saharan Africa (all income levels)?
Ensure brevity in your answer.  0.53. What is the ratio of the Aid flow from UN agencies (US$) of 1969 in South Asia to that in Sub-Saharan Africa (all income levels)?
Your answer should be very brief. 0.28. What is the ratio of the Aid flow from UN agencies (US$) of 1970 in South Asia to that in Sub-Saharan Africa (all income levels)?
Provide a short and direct response. 0.27. What is the ratio of the Aid flow from UN agencies (US$) in 1971 in South Asia to that in Sub-Saharan Africa (all income levels)?
Provide a succinct answer. 0.25. What is the ratio of the Aid flow from UN agencies (US$) of 1968 in South Asia to that in Sub-Saharan Africa (developing only)?
Make the answer very short. 0.53. What is the ratio of the Aid flow from UN agencies (US$) of 1969 in South Asia to that in Sub-Saharan Africa (developing only)?
Offer a very short reply. 0.28. What is the ratio of the Aid flow from UN agencies (US$) in 1970 in South Asia to that in Sub-Saharan Africa (developing only)?
Ensure brevity in your answer.  0.27. What is the ratio of the Aid flow from UN agencies (US$) in 1971 in South Asia to that in Sub-Saharan Africa (developing only)?
Give a very brief answer. 0.25. What is the ratio of the Aid flow from UN agencies (US$) in 1968 in South Asia to that in Upper middle income?
Your answer should be compact. 0.38. What is the ratio of the Aid flow from UN agencies (US$) in 1969 in South Asia to that in Upper middle income?
Ensure brevity in your answer.  0.38. What is the ratio of the Aid flow from UN agencies (US$) in 1970 in South Asia to that in Upper middle income?
Provide a short and direct response. 0.39. What is the ratio of the Aid flow from UN agencies (US$) of 1971 in South Asia to that in Upper middle income?
Make the answer very short. 0.35. What is the ratio of the Aid flow from UN agencies (US$) of 1969 in Sub-Saharan Africa (all income levels) to that in Sub-Saharan Africa (developing only)?
Your answer should be very brief. 1. What is the ratio of the Aid flow from UN agencies (US$) in 1971 in Sub-Saharan Africa (all income levels) to that in Sub-Saharan Africa (developing only)?
Provide a short and direct response. 1. What is the ratio of the Aid flow from UN agencies (US$) in 1968 in Sub-Saharan Africa (all income levels) to that in Upper middle income?
Give a very brief answer. 0.72. What is the ratio of the Aid flow from UN agencies (US$) of 1969 in Sub-Saharan Africa (all income levels) to that in Upper middle income?
Offer a very short reply. 1.37. What is the ratio of the Aid flow from UN agencies (US$) of 1970 in Sub-Saharan Africa (all income levels) to that in Upper middle income?
Your answer should be compact. 1.43. What is the ratio of the Aid flow from UN agencies (US$) in 1971 in Sub-Saharan Africa (all income levels) to that in Upper middle income?
Your answer should be very brief. 1.41. What is the ratio of the Aid flow from UN agencies (US$) of 1968 in Sub-Saharan Africa (developing only) to that in Upper middle income?
Offer a very short reply. 0.72. What is the ratio of the Aid flow from UN agencies (US$) in 1969 in Sub-Saharan Africa (developing only) to that in Upper middle income?
Ensure brevity in your answer.  1.37. What is the ratio of the Aid flow from UN agencies (US$) of 1970 in Sub-Saharan Africa (developing only) to that in Upper middle income?
Offer a very short reply. 1.43. What is the ratio of the Aid flow from UN agencies (US$) of 1971 in Sub-Saharan Africa (developing only) to that in Upper middle income?
Provide a short and direct response. 1.41. What is the difference between the highest and the second highest Aid flow from UN agencies (US$) of 1968?
Your answer should be very brief. 2.14e+07. What is the difference between the highest and the second highest Aid flow from UN agencies (US$) in 1970?
Offer a terse response. 0. What is the difference between the highest and the lowest Aid flow from UN agencies (US$) in 1968?
Offer a terse response. 7.54e+07. What is the difference between the highest and the lowest Aid flow from UN agencies (US$) of 1969?
Make the answer very short. 5.74e+07. What is the difference between the highest and the lowest Aid flow from UN agencies (US$) in 1970?
Your response must be concise. 6.80e+07. What is the difference between the highest and the lowest Aid flow from UN agencies (US$) of 1971?
Your answer should be very brief. 7.92e+07. 